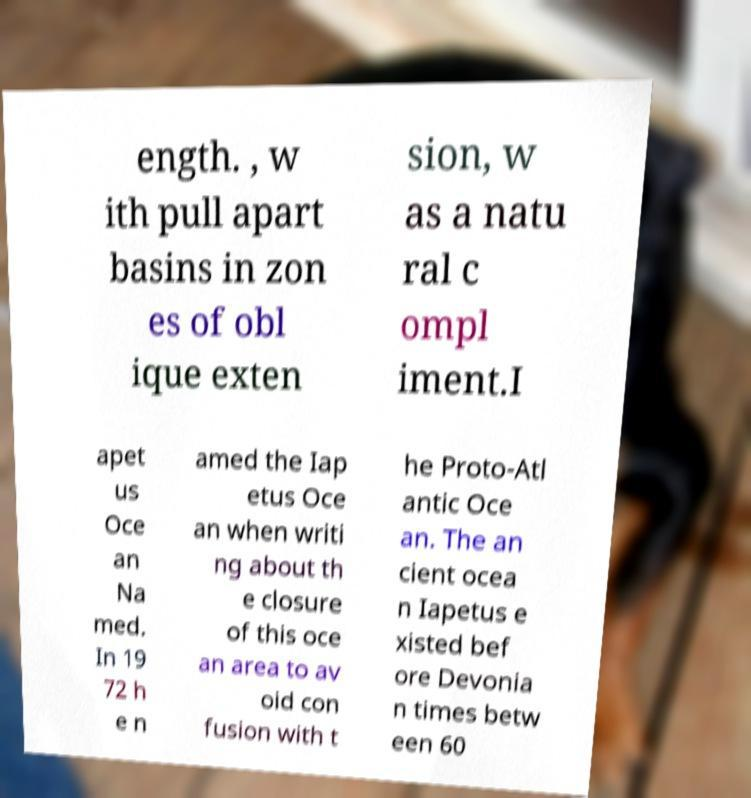There's text embedded in this image that I need extracted. Can you transcribe it verbatim? ength. , w ith pull apart basins in zon es of obl ique exten sion, w as a natu ral c ompl iment.I apet us Oce an Na med. In 19 72 h e n amed the Iap etus Oce an when writi ng about th e closure of this oce an area to av oid con fusion with t he Proto-Atl antic Oce an. The an cient ocea n Iapetus e xisted bef ore Devonia n times betw een 60 